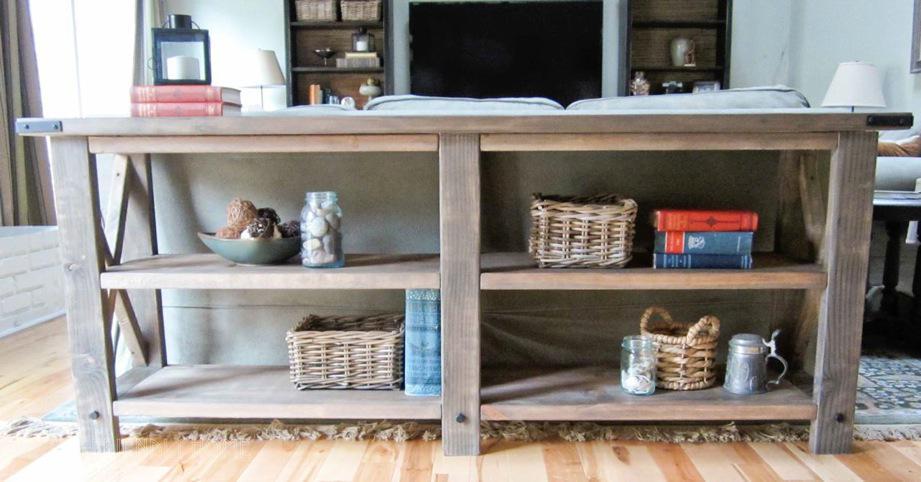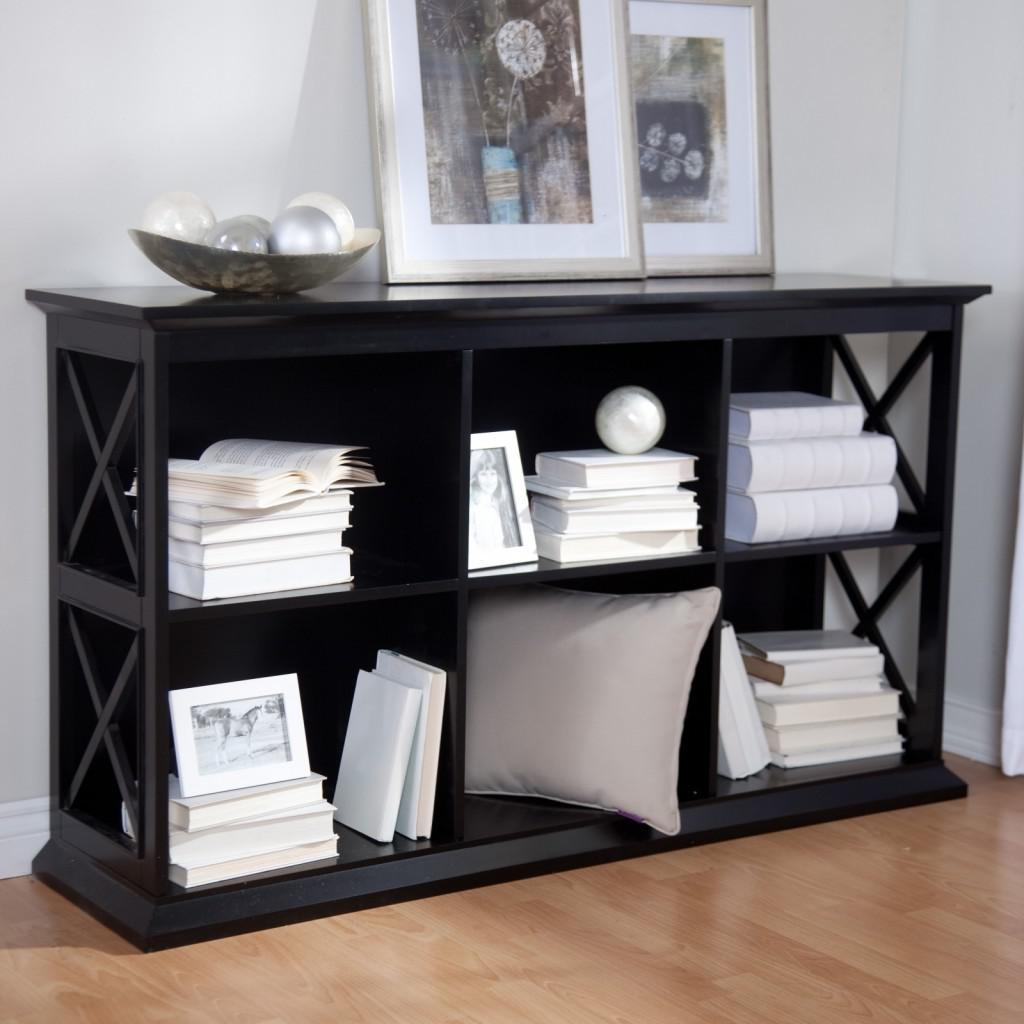The first image is the image on the left, the second image is the image on the right. Evaluate the accuracy of this statement regarding the images: "Each shelving unit is wider than it is tall and has exactly two shelf levels, but one sits flush on the floor and the other has short legs.". Is it true? Answer yes or no. Yes. The first image is the image on the left, the second image is the image on the right. Analyze the images presented: Is the assertion "There is a plant on top of a shelf in at least one of the images." valid? Answer yes or no. No. 